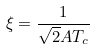<formula> <loc_0><loc_0><loc_500><loc_500>\xi = \frac { 1 } { \sqrt { 2 } A T _ { c } }</formula> 